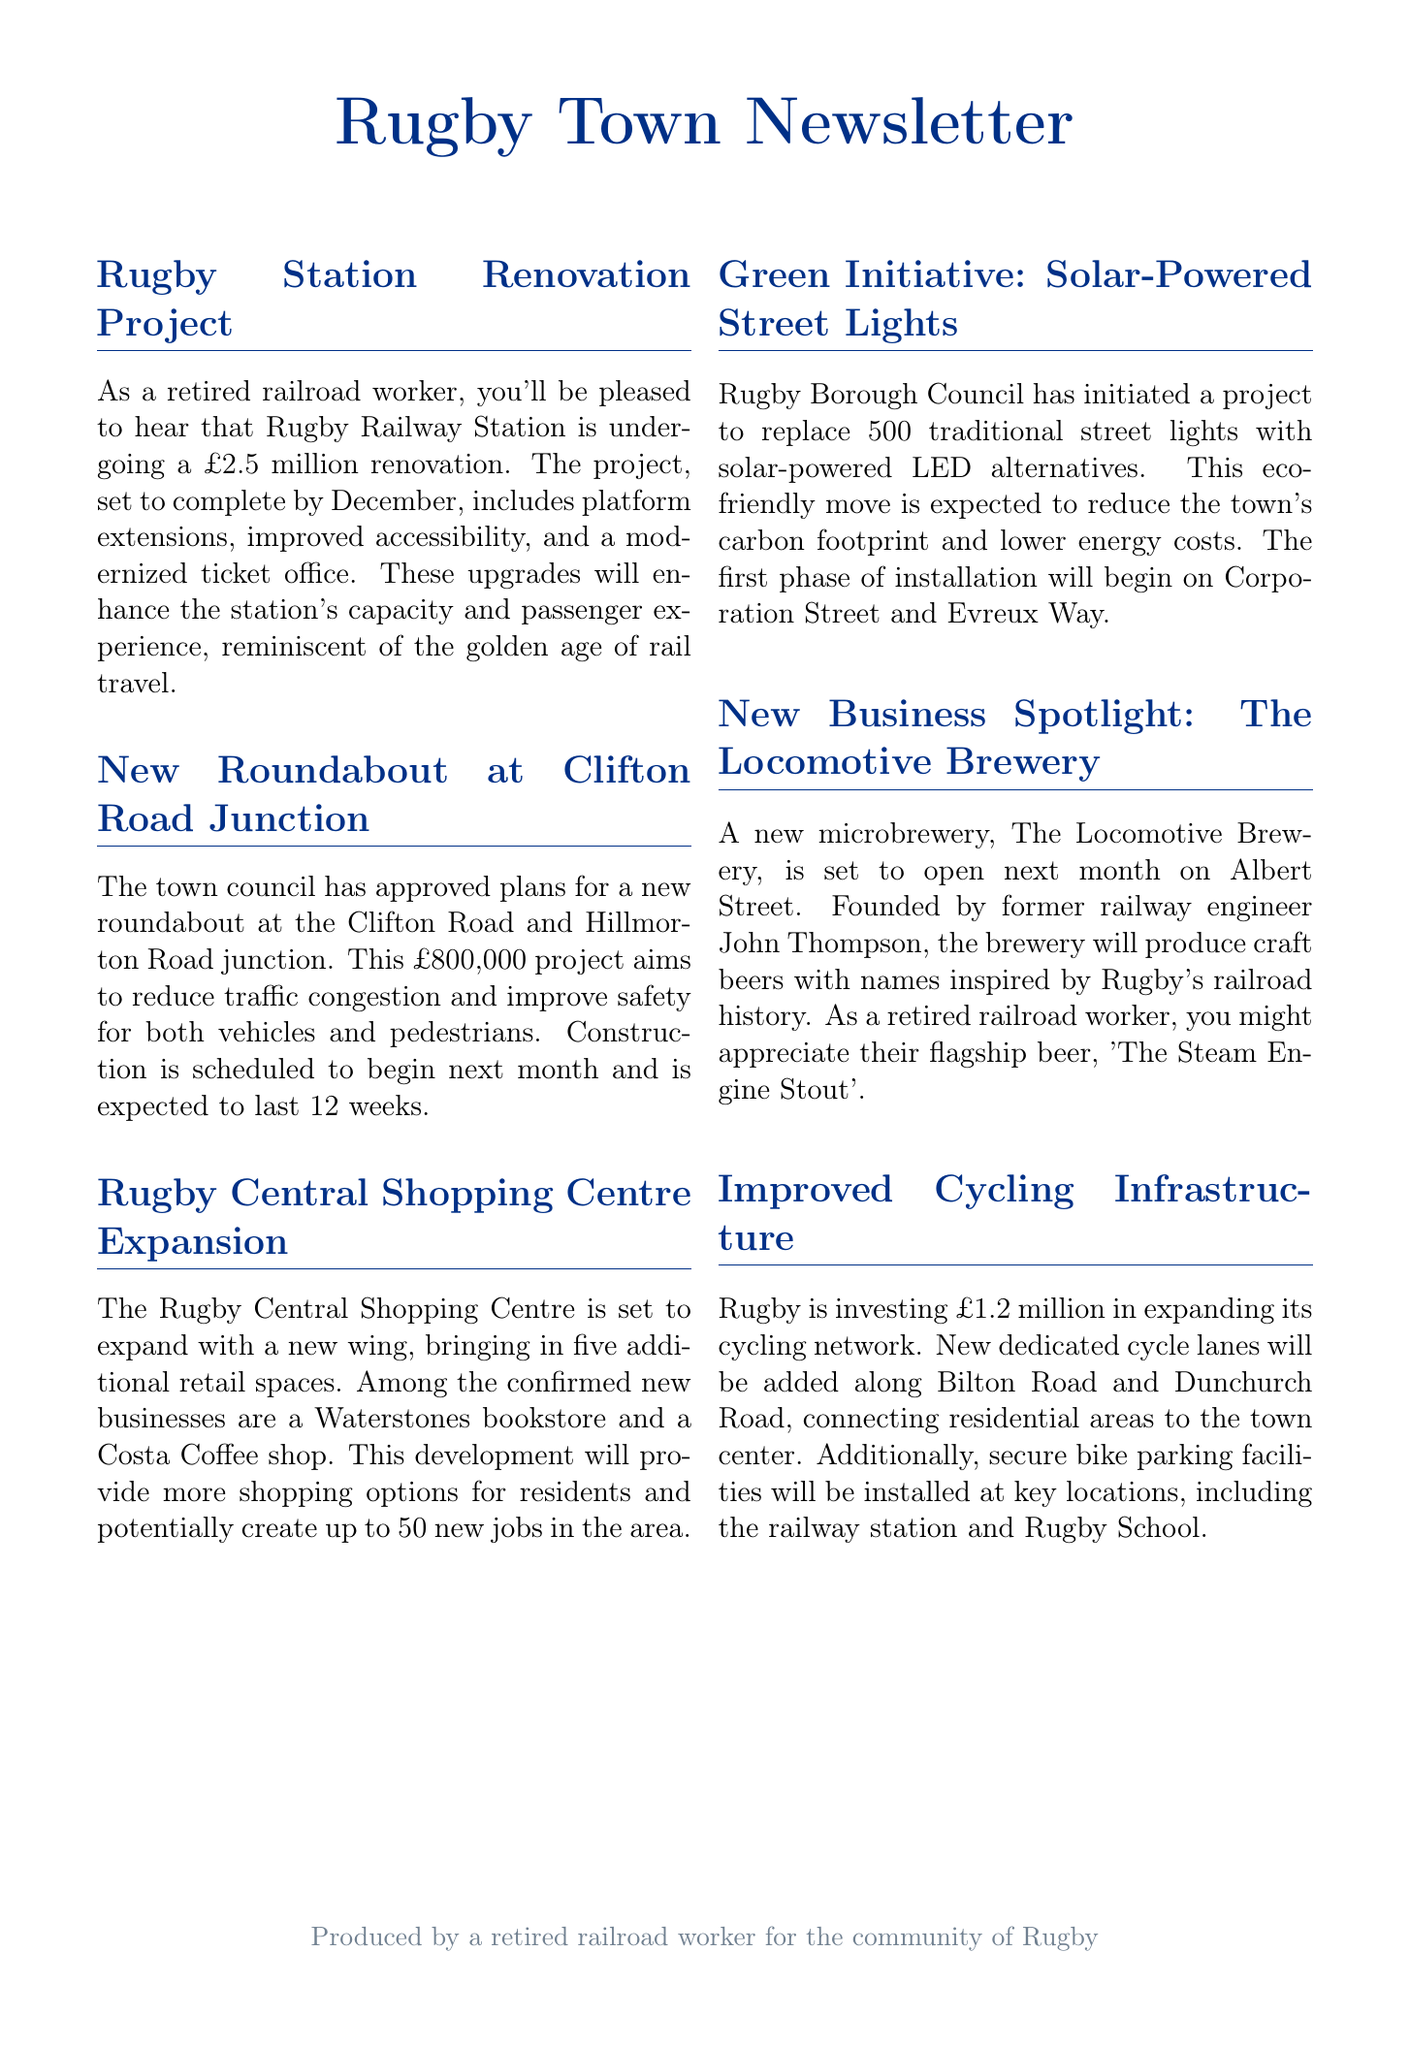What is the budget for the Rugby Station renovation? The budget for the Rugby Station renovation is explicitly mentioned in the document as £2.5 million.
Answer: £2.5 million When is the Rugby Station renovation expected to complete? The expected completion date for the Rugby Station renovation project is specified as December.
Answer: December How many new retail spaces will be created in Rugby Central Shopping Centre? The number of new retail spaces to be created in the Rugby Central Shopping Centre is stated as five.
Answer: five What is the cost of the roundabout project at Clifton Road Junction? The town council has approved the roundabout project at a cost of £800,000, as noted in the document.
Answer: £800,000 What is the primary purpose of the cycling infrastructure investment? The investment in cycling infrastructure is aimed at expanding the cycling network, which is stated in the document.
Answer: expanding the cycling network What is the name of the new microbrewery opening in Rugby? The name of the new microbrewery mentioned in the document is The Locomotive Brewery.
Answer: The Locomotive Brewery How many traditional street lights will be replaced? The exact number of traditional street lights to be replaced is specified in the document as 500.
Answer: 500 What type of beer is highlighted from The Locomotive Brewery? The flagship beer from The Locomotive Brewery, as mentioned in the document, is called 'The Steam Engine Stout'.
Answer: 'The Steam Engine Stout' How many jobs might the Rugby Central Shopping Centre expansion create? The document indicates that the expansion could potentially create up to 50 new jobs.
Answer: up to 50 new jobs 